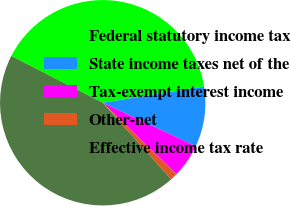Convert chart to OTSL. <chart><loc_0><loc_0><loc_500><loc_500><pie_chart><fcel>Federal statutory income tax<fcel>State income taxes net of the<fcel>Tax-exempt interest income<fcel>Other-net<fcel>Effective income tax rate<nl><fcel>39.95%<fcel>9.47%<fcel>5.31%<fcel>1.14%<fcel>44.12%<nl></chart> 